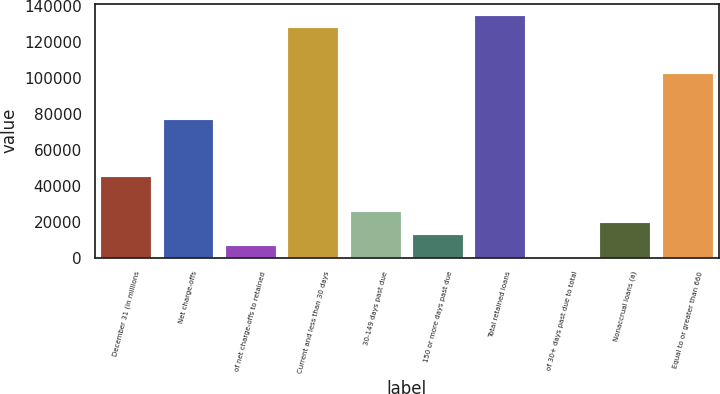<chart> <loc_0><loc_0><loc_500><loc_500><bar_chart><fcel>December 31 (in millions<fcel>Net charge-offs<fcel>of net charge-offs to retained<fcel>Current and less than 30 days<fcel>30-149 days past due<fcel>150 or more days past due<fcel>Total retained loans<fcel>of 30+ days past due to total<fcel>Nonaccrual loans (a)<fcel>Equal to or greater than 660<nl><fcel>44807.1<fcel>76810.3<fcel>6403.28<fcel>128015<fcel>25605.2<fcel>12803.9<fcel>134416<fcel>2.65<fcel>19204.6<fcel>102413<nl></chart> 